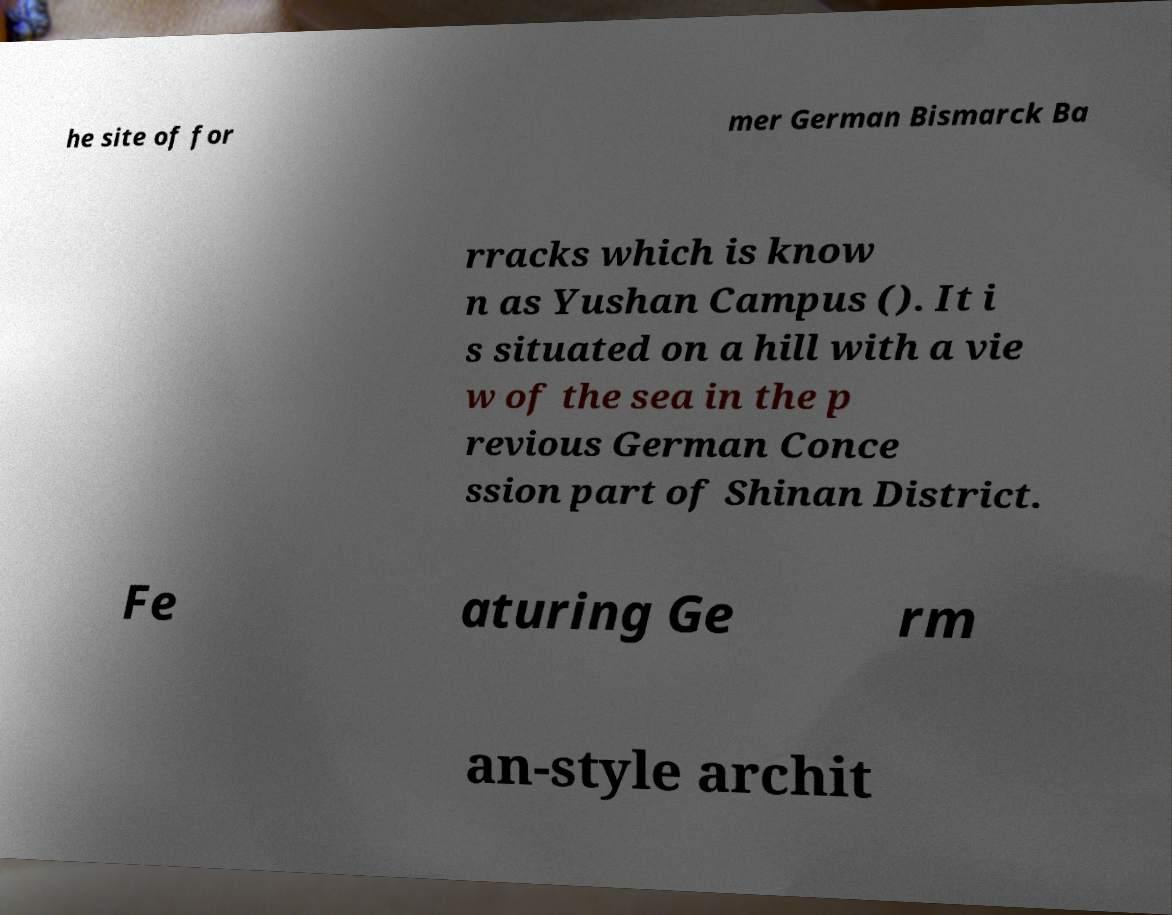There's text embedded in this image that I need extracted. Can you transcribe it verbatim? he site of for mer German Bismarck Ba rracks which is know n as Yushan Campus (). It i s situated on a hill with a vie w of the sea in the p revious German Conce ssion part of Shinan District. Fe aturing Ge rm an-style archit 